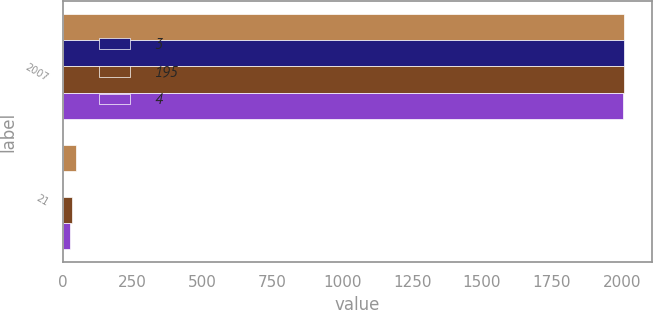Convert chart. <chart><loc_0><loc_0><loc_500><loc_500><stacked_bar_chart><ecel><fcel>2007<fcel>21<nl><fcel>nan<fcel>2007<fcel>47<nl><fcel>3<fcel>2007<fcel>2<nl><fcel>195<fcel>2007<fcel>32<nl><fcel>4<fcel>2006<fcel>25<nl></chart> 